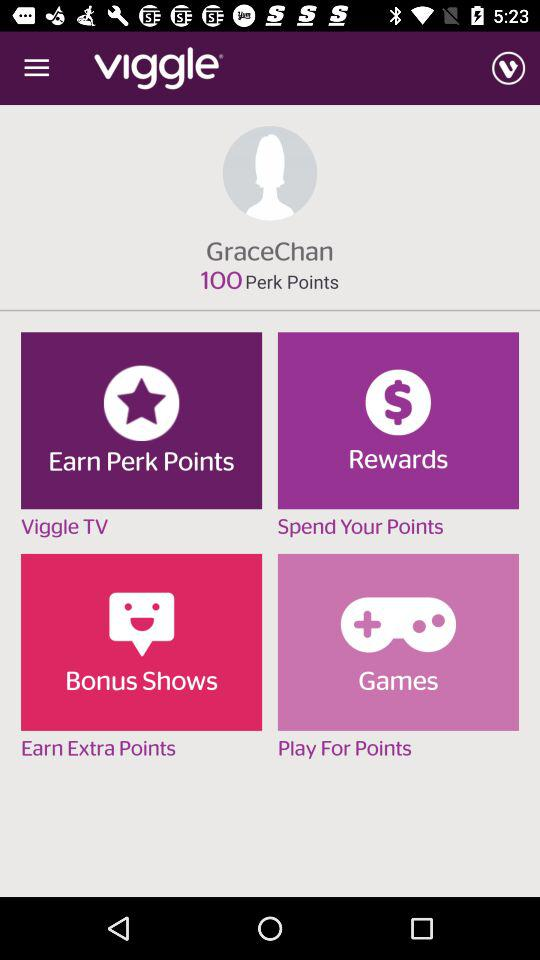What is the username? The username is "GraceChan". 